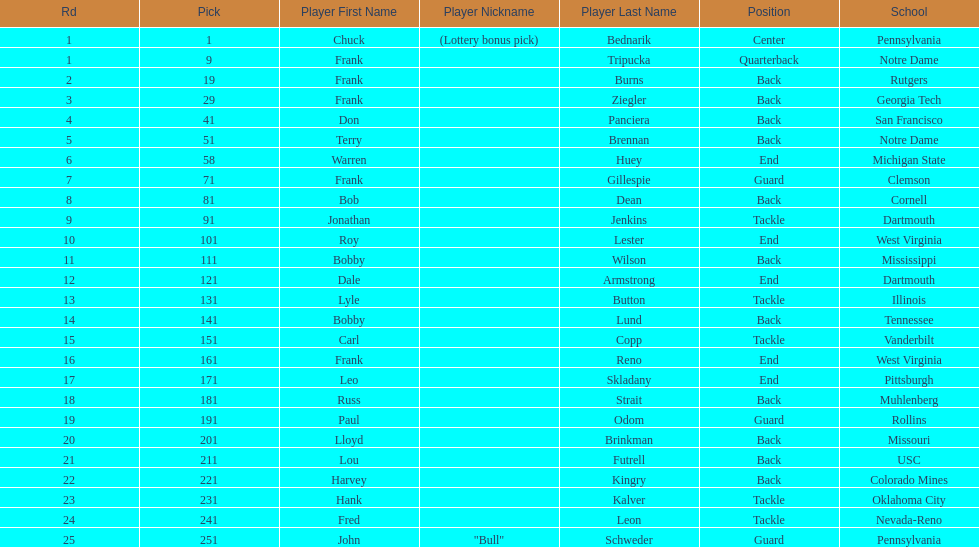How many draft picks were between frank tripucka and dale armstrong? 10. 